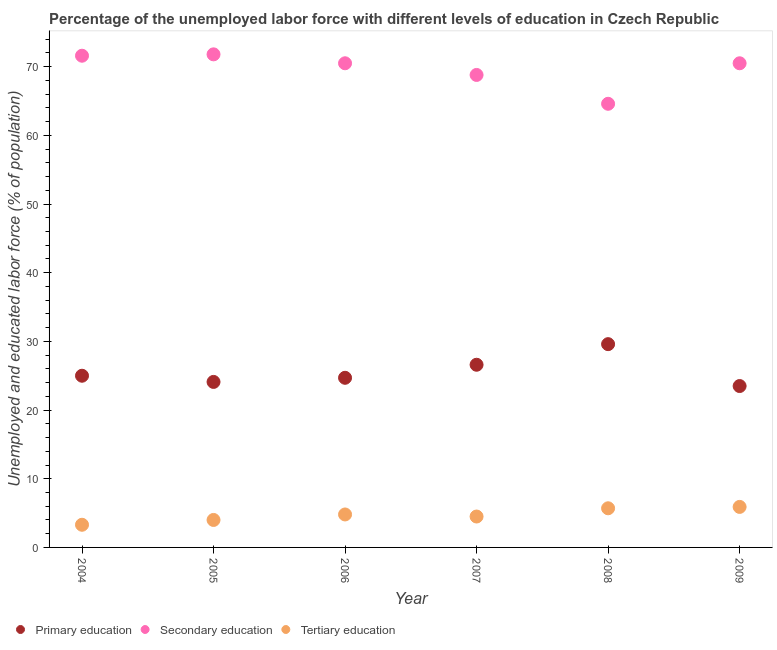How many different coloured dotlines are there?
Your answer should be compact. 3. What is the percentage of labor force who received tertiary education in 2004?
Give a very brief answer. 3.3. Across all years, what is the maximum percentage of labor force who received primary education?
Offer a terse response. 29.6. Across all years, what is the minimum percentage of labor force who received tertiary education?
Make the answer very short. 3.3. What is the total percentage of labor force who received secondary education in the graph?
Provide a succinct answer. 417.8. What is the difference between the percentage of labor force who received secondary education in 2004 and that in 2009?
Make the answer very short. 1.1. What is the difference between the percentage of labor force who received primary education in 2006 and the percentage of labor force who received tertiary education in 2005?
Offer a very short reply. 20.7. What is the average percentage of labor force who received secondary education per year?
Provide a short and direct response. 69.63. In the year 2006, what is the difference between the percentage of labor force who received primary education and percentage of labor force who received tertiary education?
Keep it short and to the point. 19.9. In how many years, is the percentage of labor force who received tertiary education greater than 68 %?
Offer a terse response. 0. What is the ratio of the percentage of labor force who received tertiary education in 2006 to that in 2009?
Provide a succinct answer. 0.81. Is the percentage of labor force who received tertiary education in 2008 less than that in 2009?
Your answer should be very brief. Yes. Is the difference between the percentage of labor force who received primary education in 2006 and 2007 greater than the difference between the percentage of labor force who received tertiary education in 2006 and 2007?
Your answer should be very brief. No. What is the difference between the highest and the second highest percentage of labor force who received primary education?
Offer a terse response. 3. What is the difference between the highest and the lowest percentage of labor force who received primary education?
Your answer should be very brief. 6.1. In how many years, is the percentage of labor force who received primary education greater than the average percentage of labor force who received primary education taken over all years?
Provide a short and direct response. 2. Is the sum of the percentage of labor force who received tertiary education in 2007 and 2008 greater than the maximum percentage of labor force who received primary education across all years?
Your response must be concise. No. Is it the case that in every year, the sum of the percentage of labor force who received primary education and percentage of labor force who received secondary education is greater than the percentage of labor force who received tertiary education?
Keep it short and to the point. Yes. Does the percentage of labor force who received primary education monotonically increase over the years?
Provide a succinct answer. No. How many years are there in the graph?
Offer a very short reply. 6. What is the difference between two consecutive major ticks on the Y-axis?
Provide a short and direct response. 10. Does the graph contain grids?
Your answer should be very brief. No. Where does the legend appear in the graph?
Provide a short and direct response. Bottom left. How many legend labels are there?
Provide a short and direct response. 3. How are the legend labels stacked?
Make the answer very short. Horizontal. What is the title of the graph?
Provide a short and direct response. Percentage of the unemployed labor force with different levels of education in Czech Republic. What is the label or title of the Y-axis?
Provide a short and direct response. Unemployed and educated labor force (% of population). What is the Unemployed and educated labor force (% of population) in Secondary education in 2004?
Keep it short and to the point. 71.6. What is the Unemployed and educated labor force (% of population) of Tertiary education in 2004?
Make the answer very short. 3.3. What is the Unemployed and educated labor force (% of population) of Primary education in 2005?
Offer a very short reply. 24.1. What is the Unemployed and educated labor force (% of population) in Secondary education in 2005?
Provide a short and direct response. 71.8. What is the Unemployed and educated labor force (% of population) in Tertiary education in 2005?
Offer a very short reply. 4. What is the Unemployed and educated labor force (% of population) in Primary education in 2006?
Your answer should be very brief. 24.7. What is the Unemployed and educated labor force (% of population) in Secondary education in 2006?
Offer a terse response. 70.5. What is the Unemployed and educated labor force (% of population) in Tertiary education in 2006?
Keep it short and to the point. 4.8. What is the Unemployed and educated labor force (% of population) of Primary education in 2007?
Provide a succinct answer. 26.6. What is the Unemployed and educated labor force (% of population) in Secondary education in 2007?
Offer a very short reply. 68.8. What is the Unemployed and educated labor force (% of population) in Primary education in 2008?
Offer a very short reply. 29.6. What is the Unemployed and educated labor force (% of population) of Secondary education in 2008?
Provide a short and direct response. 64.6. What is the Unemployed and educated labor force (% of population) in Tertiary education in 2008?
Give a very brief answer. 5.7. What is the Unemployed and educated labor force (% of population) of Secondary education in 2009?
Your answer should be very brief. 70.5. What is the Unemployed and educated labor force (% of population) of Tertiary education in 2009?
Offer a very short reply. 5.9. Across all years, what is the maximum Unemployed and educated labor force (% of population) of Primary education?
Your answer should be compact. 29.6. Across all years, what is the maximum Unemployed and educated labor force (% of population) of Secondary education?
Your answer should be compact. 71.8. Across all years, what is the maximum Unemployed and educated labor force (% of population) in Tertiary education?
Keep it short and to the point. 5.9. Across all years, what is the minimum Unemployed and educated labor force (% of population) of Secondary education?
Make the answer very short. 64.6. Across all years, what is the minimum Unemployed and educated labor force (% of population) in Tertiary education?
Offer a very short reply. 3.3. What is the total Unemployed and educated labor force (% of population) in Primary education in the graph?
Give a very brief answer. 153.5. What is the total Unemployed and educated labor force (% of population) in Secondary education in the graph?
Provide a succinct answer. 417.8. What is the total Unemployed and educated labor force (% of population) of Tertiary education in the graph?
Make the answer very short. 28.2. What is the difference between the Unemployed and educated labor force (% of population) in Secondary education in 2004 and that in 2005?
Keep it short and to the point. -0.2. What is the difference between the Unemployed and educated labor force (% of population) in Tertiary education in 2004 and that in 2005?
Your answer should be compact. -0.7. What is the difference between the Unemployed and educated labor force (% of population) of Secondary education in 2004 and that in 2006?
Your answer should be compact. 1.1. What is the difference between the Unemployed and educated labor force (% of population) in Tertiary education in 2004 and that in 2006?
Make the answer very short. -1.5. What is the difference between the Unemployed and educated labor force (% of population) in Primary education in 2004 and that in 2007?
Provide a succinct answer. -1.6. What is the difference between the Unemployed and educated labor force (% of population) of Secondary education in 2004 and that in 2007?
Offer a terse response. 2.8. What is the difference between the Unemployed and educated labor force (% of population) in Tertiary education in 2004 and that in 2007?
Give a very brief answer. -1.2. What is the difference between the Unemployed and educated labor force (% of population) of Secondary education in 2004 and that in 2008?
Provide a short and direct response. 7. What is the difference between the Unemployed and educated labor force (% of population) in Tertiary education in 2004 and that in 2009?
Give a very brief answer. -2.6. What is the difference between the Unemployed and educated labor force (% of population) in Primary education in 2005 and that in 2006?
Provide a succinct answer. -0.6. What is the difference between the Unemployed and educated labor force (% of population) in Secondary education in 2005 and that in 2006?
Your response must be concise. 1.3. What is the difference between the Unemployed and educated labor force (% of population) in Tertiary education in 2005 and that in 2006?
Offer a very short reply. -0.8. What is the difference between the Unemployed and educated labor force (% of population) in Primary education in 2005 and that in 2007?
Keep it short and to the point. -2.5. What is the difference between the Unemployed and educated labor force (% of population) of Secondary education in 2005 and that in 2007?
Your answer should be very brief. 3. What is the difference between the Unemployed and educated labor force (% of population) in Tertiary education in 2005 and that in 2007?
Make the answer very short. -0.5. What is the difference between the Unemployed and educated labor force (% of population) of Secondary education in 2005 and that in 2008?
Ensure brevity in your answer.  7.2. What is the difference between the Unemployed and educated labor force (% of population) in Tertiary education in 2005 and that in 2008?
Your response must be concise. -1.7. What is the difference between the Unemployed and educated labor force (% of population) in Tertiary education in 2005 and that in 2009?
Provide a short and direct response. -1.9. What is the difference between the Unemployed and educated labor force (% of population) of Secondary education in 2006 and that in 2007?
Your answer should be compact. 1.7. What is the difference between the Unemployed and educated labor force (% of population) of Secondary education in 2006 and that in 2008?
Offer a terse response. 5.9. What is the difference between the Unemployed and educated labor force (% of population) of Secondary education in 2006 and that in 2009?
Your response must be concise. 0. What is the difference between the Unemployed and educated labor force (% of population) of Tertiary education in 2006 and that in 2009?
Provide a short and direct response. -1.1. What is the difference between the Unemployed and educated labor force (% of population) in Secondary education in 2007 and that in 2009?
Make the answer very short. -1.7. What is the difference between the Unemployed and educated labor force (% of population) of Primary education in 2008 and that in 2009?
Your answer should be very brief. 6.1. What is the difference between the Unemployed and educated labor force (% of population) of Secondary education in 2008 and that in 2009?
Ensure brevity in your answer.  -5.9. What is the difference between the Unemployed and educated labor force (% of population) in Tertiary education in 2008 and that in 2009?
Keep it short and to the point. -0.2. What is the difference between the Unemployed and educated labor force (% of population) of Primary education in 2004 and the Unemployed and educated labor force (% of population) of Secondary education in 2005?
Ensure brevity in your answer.  -46.8. What is the difference between the Unemployed and educated labor force (% of population) in Primary education in 2004 and the Unemployed and educated labor force (% of population) in Tertiary education in 2005?
Give a very brief answer. 21. What is the difference between the Unemployed and educated labor force (% of population) of Secondary education in 2004 and the Unemployed and educated labor force (% of population) of Tertiary education in 2005?
Your response must be concise. 67.6. What is the difference between the Unemployed and educated labor force (% of population) of Primary education in 2004 and the Unemployed and educated labor force (% of population) of Secondary education in 2006?
Ensure brevity in your answer.  -45.5. What is the difference between the Unemployed and educated labor force (% of population) of Primary education in 2004 and the Unemployed and educated labor force (% of population) of Tertiary education in 2006?
Your response must be concise. 20.2. What is the difference between the Unemployed and educated labor force (% of population) in Secondary education in 2004 and the Unemployed and educated labor force (% of population) in Tertiary education in 2006?
Offer a very short reply. 66.8. What is the difference between the Unemployed and educated labor force (% of population) of Primary education in 2004 and the Unemployed and educated labor force (% of population) of Secondary education in 2007?
Provide a succinct answer. -43.8. What is the difference between the Unemployed and educated labor force (% of population) of Primary education in 2004 and the Unemployed and educated labor force (% of population) of Tertiary education in 2007?
Make the answer very short. 20.5. What is the difference between the Unemployed and educated labor force (% of population) of Secondary education in 2004 and the Unemployed and educated labor force (% of population) of Tertiary education in 2007?
Keep it short and to the point. 67.1. What is the difference between the Unemployed and educated labor force (% of population) of Primary education in 2004 and the Unemployed and educated labor force (% of population) of Secondary education in 2008?
Ensure brevity in your answer.  -39.6. What is the difference between the Unemployed and educated labor force (% of population) in Primary education in 2004 and the Unemployed and educated labor force (% of population) in Tertiary education in 2008?
Make the answer very short. 19.3. What is the difference between the Unemployed and educated labor force (% of population) in Secondary education in 2004 and the Unemployed and educated labor force (% of population) in Tertiary education in 2008?
Keep it short and to the point. 65.9. What is the difference between the Unemployed and educated labor force (% of population) of Primary education in 2004 and the Unemployed and educated labor force (% of population) of Secondary education in 2009?
Provide a succinct answer. -45.5. What is the difference between the Unemployed and educated labor force (% of population) in Primary education in 2004 and the Unemployed and educated labor force (% of population) in Tertiary education in 2009?
Your answer should be very brief. 19.1. What is the difference between the Unemployed and educated labor force (% of population) in Secondary education in 2004 and the Unemployed and educated labor force (% of population) in Tertiary education in 2009?
Keep it short and to the point. 65.7. What is the difference between the Unemployed and educated labor force (% of population) of Primary education in 2005 and the Unemployed and educated labor force (% of population) of Secondary education in 2006?
Your answer should be compact. -46.4. What is the difference between the Unemployed and educated labor force (% of population) in Primary education in 2005 and the Unemployed and educated labor force (% of population) in Tertiary education in 2006?
Give a very brief answer. 19.3. What is the difference between the Unemployed and educated labor force (% of population) in Primary education in 2005 and the Unemployed and educated labor force (% of population) in Secondary education in 2007?
Offer a very short reply. -44.7. What is the difference between the Unemployed and educated labor force (% of population) of Primary education in 2005 and the Unemployed and educated labor force (% of population) of Tertiary education in 2007?
Give a very brief answer. 19.6. What is the difference between the Unemployed and educated labor force (% of population) of Secondary education in 2005 and the Unemployed and educated labor force (% of population) of Tertiary education in 2007?
Your answer should be very brief. 67.3. What is the difference between the Unemployed and educated labor force (% of population) in Primary education in 2005 and the Unemployed and educated labor force (% of population) in Secondary education in 2008?
Offer a terse response. -40.5. What is the difference between the Unemployed and educated labor force (% of population) in Secondary education in 2005 and the Unemployed and educated labor force (% of population) in Tertiary education in 2008?
Offer a terse response. 66.1. What is the difference between the Unemployed and educated labor force (% of population) of Primary education in 2005 and the Unemployed and educated labor force (% of population) of Secondary education in 2009?
Provide a short and direct response. -46.4. What is the difference between the Unemployed and educated labor force (% of population) in Secondary education in 2005 and the Unemployed and educated labor force (% of population) in Tertiary education in 2009?
Make the answer very short. 65.9. What is the difference between the Unemployed and educated labor force (% of population) of Primary education in 2006 and the Unemployed and educated labor force (% of population) of Secondary education in 2007?
Offer a terse response. -44.1. What is the difference between the Unemployed and educated labor force (% of population) in Primary education in 2006 and the Unemployed and educated labor force (% of population) in Tertiary education in 2007?
Ensure brevity in your answer.  20.2. What is the difference between the Unemployed and educated labor force (% of population) in Primary education in 2006 and the Unemployed and educated labor force (% of population) in Secondary education in 2008?
Offer a terse response. -39.9. What is the difference between the Unemployed and educated labor force (% of population) of Primary education in 2006 and the Unemployed and educated labor force (% of population) of Tertiary education in 2008?
Provide a succinct answer. 19. What is the difference between the Unemployed and educated labor force (% of population) in Secondary education in 2006 and the Unemployed and educated labor force (% of population) in Tertiary education in 2008?
Make the answer very short. 64.8. What is the difference between the Unemployed and educated labor force (% of population) of Primary education in 2006 and the Unemployed and educated labor force (% of population) of Secondary education in 2009?
Keep it short and to the point. -45.8. What is the difference between the Unemployed and educated labor force (% of population) in Primary education in 2006 and the Unemployed and educated labor force (% of population) in Tertiary education in 2009?
Give a very brief answer. 18.8. What is the difference between the Unemployed and educated labor force (% of population) of Secondary education in 2006 and the Unemployed and educated labor force (% of population) of Tertiary education in 2009?
Your answer should be compact. 64.6. What is the difference between the Unemployed and educated labor force (% of population) of Primary education in 2007 and the Unemployed and educated labor force (% of population) of Secondary education in 2008?
Your response must be concise. -38. What is the difference between the Unemployed and educated labor force (% of population) of Primary education in 2007 and the Unemployed and educated labor force (% of population) of Tertiary education in 2008?
Make the answer very short. 20.9. What is the difference between the Unemployed and educated labor force (% of population) of Secondary education in 2007 and the Unemployed and educated labor force (% of population) of Tertiary education in 2008?
Offer a terse response. 63.1. What is the difference between the Unemployed and educated labor force (% of population) of Primary education in 2007 and the Unemployed and educated labor force (% of population) of Secondary education in 2009?
Offer a terse response. -43.9. What is the difference between the Unemployed and educated labor force (% of population) in Primary education in 2007 and the Unemployed and educated labor force (% of population) in Tertiary education in 2009?
Your answer should be very brief. 20.7. What is the difference between the Unemployed and educated labor force (% of population) of Secondary education in 2007 and the Unemployed and educated labor force (% of population) of Tertiary education in 2009?
Offer a terse response. 62.9. What is the difference between the Unemployed and educated labor force (% of population) in Primary education in 2008 and the Unemployed and educated labor force (% of population) in Secondary education in 2009?
Offer a very short reply. -40.9. What is the difference between the Unemployed and educated labor force (% of population) in Primary education in 2008 and the Unemployed and educated labor force (% of population) in Tertiary education in 2009?
Offer a very short reply. 23.7. What is the difference between the Unemployed and educated labor force (% of population) in Secondary education in 2008 and the Unemployed and educated labor force (% of population) in Tertiary education in 2009?
Give a very brief answer. 58.7. What is the average Unemployed and educated labor force (% of population) in Primary education per year?
Your answer should be compact. 25.58. What is the average Unemployed and educated labor force (% of population) in Secondary education per year?
Provide a succinct answer. 69.63. What is the average Unemployed and educated labor force (% of population) of Tertiary education per year?
Your response must be concise. 4.7. In the year 2004, what is the difference between the Unemployed and educated labor force (% of population) of Primary education and Unemployed and educated labor force (% of population) of Secondary education?
Provide a succinct answer. -46.6. In the year 2004, what is the difference between the Unemployed and educated labor force (% of population) in Primary education and Unemployed and educated labor force (% of population) in Tertiary education?
Offer a terse response. 21.7. In the year 2004, what is the difference between the Unemployed and educated labor force (% of population) in Secondary education and Unemployed and educated labor force (% of population) in Tertiary education?
Your response must be concise. 68.3. In the year 2005, what is the difference between the Unemployed and educated labor force (% of population) of Primary education and Unemployed and educated labor force (% of population) of Secondary education?
Ensure brevity in your answer.  -47.7. In the year 2005, what is the difference between the Unemployed and educated labor force (% of population) of Primary education and Unemployed and educated labor force (% of population) of Tertiary education?
Ensure brevity in your answer.  20.1. In the year 2005, what is the difference between the Unemployed and educated labor force (% of population) of Secondary education and Unemployed and educated labor force (% of population) of Tertiary education?
Make the answer very short. 67.8. In the year 2006, what is the difference between the Unemployed and educated labor force (% of population) in Primary education and Unemployed and educated labor force (% of population) in Secondary education?
Offer a terse response. -45.8. In the year 2006, what is the difference between the Unemployed and educated labor force (% of population) in Secondary education and Unemployed and educated labor force (% of population) in Tertiary education?
Keep it short and to the point. 65.7. In the year 2007, what is the difference between the Unemployed and educated labor force (% of population) in Primary education and Unemployed and educated labor force (% of population) in Secondary education?
Keep it short and to the point. -42.2. In the year 2007, what is the difference between the Unemployed and educated labor force (% of population) in Primary education and Unemployed and educated labor force (% of population) in Tertiary education?
Offer a very short reply. 22.1. In the year 2007, what is the difference between the Unemployed and educated labor force (% of population) in Secondary education and Unemployed and educated labor force (% of population) in Tertiary education?
Keep it short and to the point. 64.3. In the year 2008, what is the difference between the Unemployed and educated labor force (% of population) in Primary education and Unemployed and educated labor force (% of population) in Secondary education?
Your answer should be very brief. -35. In the year 2008, what is the difference between the Unemployed and educated labor force (% of population) of Primary education and Unemployed and educated labor force (% of population) of Tertiary education?
Your response must be concise. 23.9. In the year 2008, what is the difference between the Unemployed and educated labor force (% of population) of Secondary education and Unemployed and educated labor force (% of population) of Tertiary education?
Your response must be concise. 58.9. In the year 2009, what is the difference between the Unemployed and educated labor force (% of population) in Primary education and Unemployed and educated labor force (% of population) in Secondary education?
Give a very brief answer. -47. In the year 2009, what is the difference between the Unemployed and educated labor force (% of population) of Secondary education and Unemployed and educated labor force (% of population) of Tertiary education?
Your answer should be compact. 64.6. What is the ratio of the Unemployed and educated labor force (% of population) in Primary education in 2004 to that in 2005?
Offer a terse response. 1.04. What is the ratio of the Unemployed and educated labor force (% of population) in Secondary education in 2004 to that in 2005?
Your response must be concise. 1. What is the ratio of the Unemployed and educated labor force (% of population) of Tertiary education in 2004 to that in 2005?
Your answer should be compact. 0.82. What is the ratio of the Unemployed and educated labor force (% of population) of Primary education in 2004 to that in 2006?
Your response must be concise. 1.01. What is the ratio of the Unemployed and educated labor force (% of population) in Secondary education in 2004 to that in 2006?
Offer a terse response. 1.02. What is the ratio of the Unemployed and educated labor force (% of population) in Tertiary education in 2004 to that in 2006?
Provide a succinct answer. 0.69. What is the ratio of the Unemployed and educated labor force (% of population) of Primary education in 2004 to that in 2007?
Give a very brief answer. 0.94. What is the ratio of the Unemployed and educated labor force (% of population) in Secondary education in 2004 to that in 2007?
Provide a short and direct response. 1.04. What is the ratio of the Unemployed and educated labor force (% of population) of Tertiary education in 2004 to that in 2007?
Make the answer very short. 0.73. What is the ratio of the Unemployed and educated labor force (% of population) in Primary education in 2004 to that in 2008?
Keep it short and to the point. 0.84. What is the ratio of the Unemployed and educated labor force (% of population) of Secondary education in 2004 to that in 2008?
Provide a succinct answer. 1.11. What is the ratio of the Unemployed and educated labor force (% of population) in Tertiary education in 2004 to that in 2008?
Your response must be concise. 0.58. What is the ratio of the Unemployed and educated labor force (% of population) of Primary education in 2004 to that in 2009?
Your answer should be compact. 1.06. What is the ratio of the Unemployed and educated labor force (% of population) in Secondary education in 2004 to that in 2009?
Make the answer very short. 1.02. What is the ratio of the Unemployed and educated labor force (% of population) of Tertiary education in 2004 to that in 2009?
Your answer should be very brief. 0.56. What is the ratio of the Unemployed and educated labor force (% of population) in Primary education in 2005 to that in 2006?
Your answer should be compact. 0.98. What is the ratio of the Unemployed and educated labor force (% of population) in Secondary education in 2005 to that in 2006?
Ensure brevity in your answer.  1.02. What is the ratio of the Unemployed and educated labor force (% of population) of Primary education in 2005 to that in 2007?
Offer a very short reply. 0.91. What is the ratio of the Unemployed and educated labor force (% of population) of Secondary education in 2005 to that in 2007?
Provide a short and direct response. 1.04. What is the ratio of the Unemployed and educated labor force (% of population) in Primary education in 2005 to that in 2008?
Offer a terse response. 0.81. What is the ratio of the Unemployed and educated labor force (% of population) in Secondary education in 2005 to that in 2008?
Keep it short and to the point. 1.11. What is the ratio of the Unemployed and educated labor force (% of population) of Tertiary education in 2005 to that in 2008?
Give a very brief answer. 0.7. What is the ratio of the Unemployed and educated labor force (% of population) in Primary education in 2005 to that in 2009?
Offer a very short reply. 1.03. What is the ratio of the Unemployed and educated labor force (% of population) in Secondary education in 2005 to that in 2009?
Keep it short and to the point. 1.02. What is the ratio of the Unemployed and educated labor force (% of population) of Tertiary education in 2005 to that in 2009?
Offer a terse response. 0.68. What is the ratio of the Unemployed and educated labor force (% of population) of Primary education in 2006 to that in 2007?
Your response must be concise. 0.93. What is the ratio of the Unemployed and educated labor force (% of population) of Secondary education in 2006 to that in 2007?
Keep it short and to the point. 1.02. What is the ratio of the Unemployed and educated labor force (% of population) of Tertiary education in 2006 to that in 2007?
Provide a succinct answer. 1.07. What is the ratio of the Unemployed and educated labor force (% of population) of Primary education in 2006 to that in 2008?
Your response must be concise. 0.83. What is the ratio of the Unemployed and educated labor force (% of population) in Secondary education in 2006 to that in 2008?
Give a very brief answer. 1.09. What is the ratio of the Unemployed and educated labor force (% of population) in Tertiary education in 2006 to that in 2008?
Offer a terse response. 0.84. What is the ratio of the Unemployed and educated labor force (% of population) of Primary education in 2006 to that in 2009?
Your answer should be very brief. 1.05. What is the ratio of the Unemployed and educated labor force (% of population) in Secondary education in 2006 to that in 2009?
Make the answer very short. 1. What is the ratio of the Unemployed and educated labor force (% of population) of Tertiary education in 2006 to that in 2009?
Offer a very short reply. 0.81. What is the ratio of the Unemployed and educated labor force (% of population) in Primary education in 2007 to that in 2008?
Your answer should be compact. 0.9. What is the ratio of the Unemployed and educated labor force (% of population) of Secondary education in 2007 to that in 2008?
Your answer should be compact. 1.06. What is the ratio of the Unemployed and educated labor force (% of population) of Tertiary education in 2007 to that in 2008?
Your answer should be very brief. 0.79. What is the ratio of the Unemployed and educated labor force (% of population) of Primary education in 2007 to that in 2009?
Your response must be concise. 1.13. What is the ratio of the Unemployed and educated labor force (% of population) of Secondary education in 2007 to that in 2009?
Your answer should be compact. 0.98. What is the ratio of the Unemployed and educated labor force (% of population) of Tertiary education in 2007 to that in 2009?
Your response must be concise. 0.76. What is the ratio of the Unemployed and educated labor force (% of population) in Primary education in 2008 to that in 2009?
Your response must be concise. 1.26. What is the ratio of the Unemployed and educated labor force (% of population) of Secondary education in 2008 to that in 2009?
Provide a short and direct response. 0.92. What is the ratio of the Unemployed and educated labor force (% of population) of Tertiary education in 2008 to that in 2009?
Make the answer very short. 0.97. What is the difference between the highest and the second highest Unemployed and educated labor force (% of population) in Secondary education?
Your response must be concise. 0.2. 